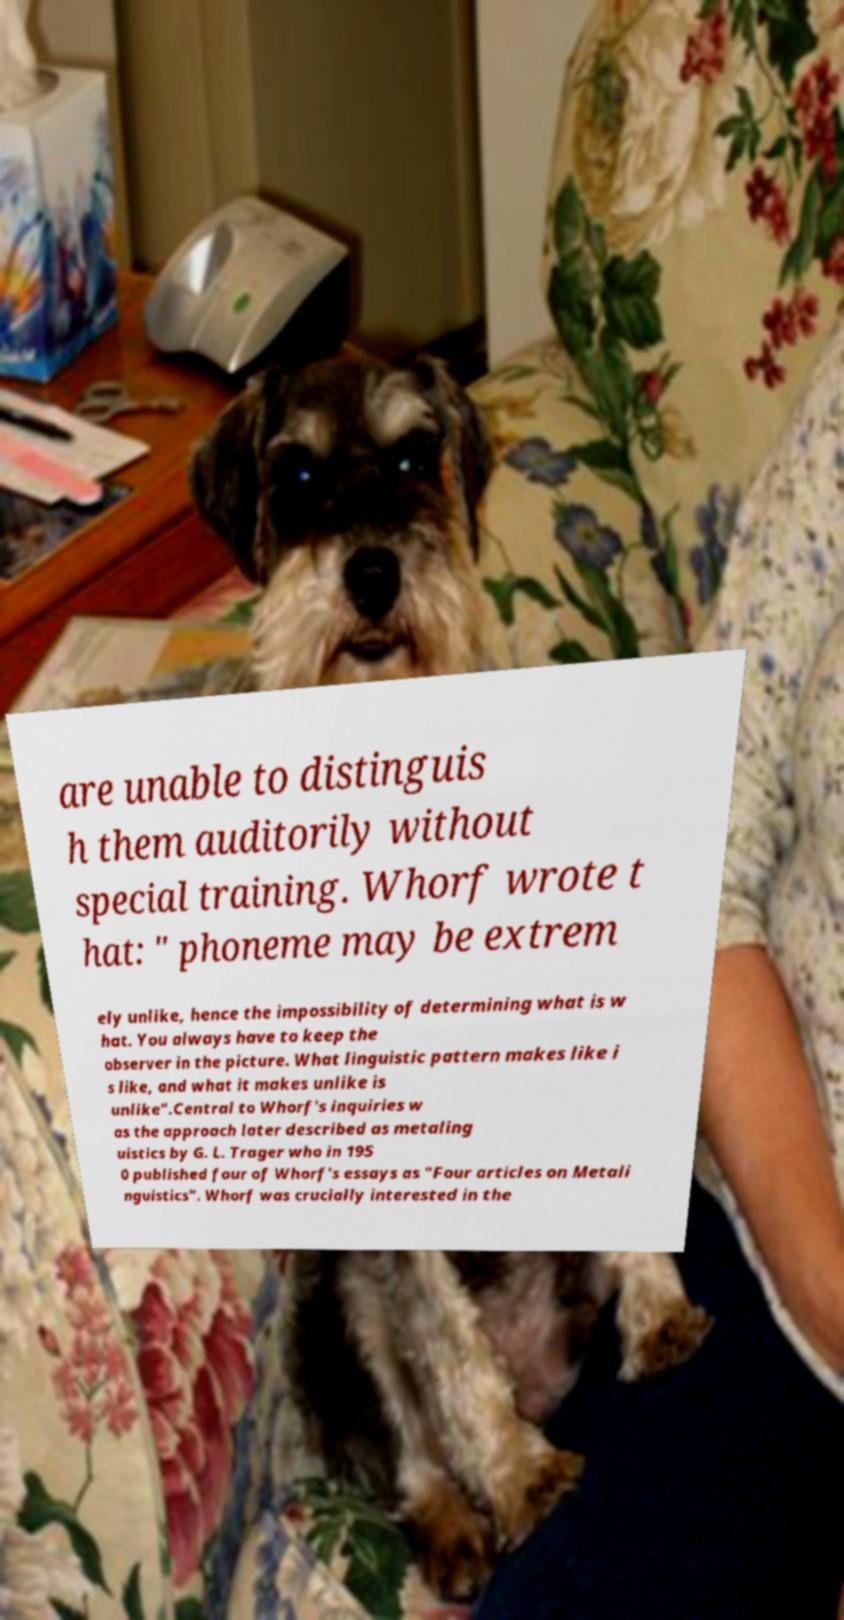There's text embedded in this image that I need extracted. Can you transcribe it verbatim? are unable to distinguis h them auditorily without special training. Whorf wrote t hat: " phoneme may be extrem ely unlike, hence the impossibility of determining what is w hat. You always have to keep the observer in the picture. What linguistic pattern makes like i s like, and what it makes unlike is unlike".Central to Whorf's inquiries w as the approach later described as metaling uistics by G. L. Trager who in 195 0 published four of Whorf's essays as "Four articles on Metali nguistics". Whorf was crucially interested in the 